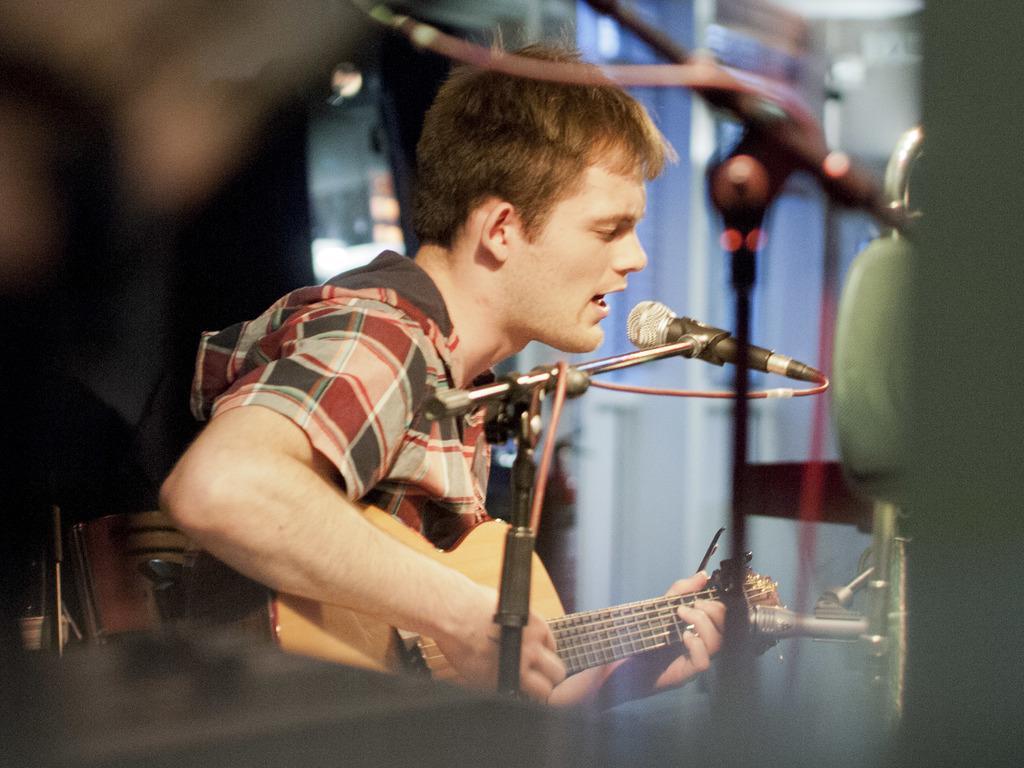Please provide a concise description of this image. In this picture we can see man sitting holding guitar in his hand playing it and singing on mic and in background we can see some mic stands, wall. 